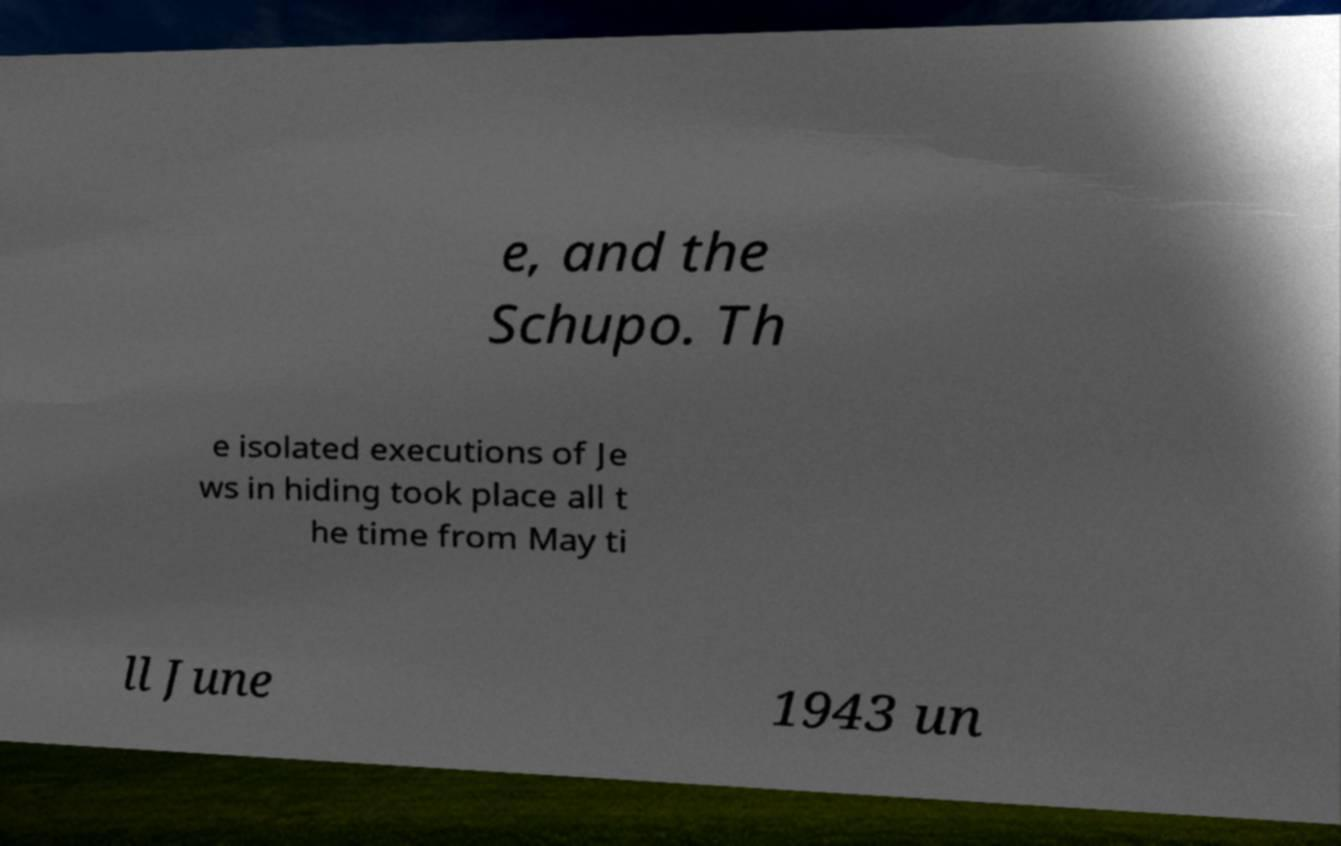What messages or text are displayed in this image? I need them in a readable, typed format. e, and the Schupo. Th e isolated executions of Je ws in hiding took place all t he time from May ti ll June 1943 un 